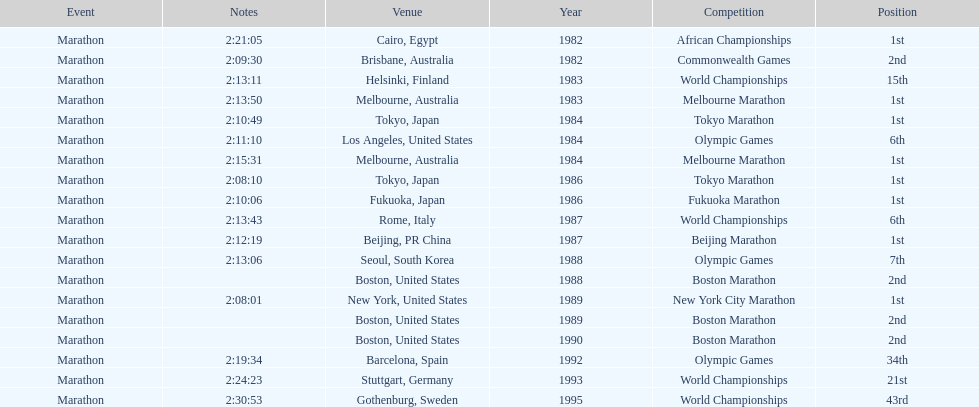In what year did the runner participate in the most marathons? 1984. 